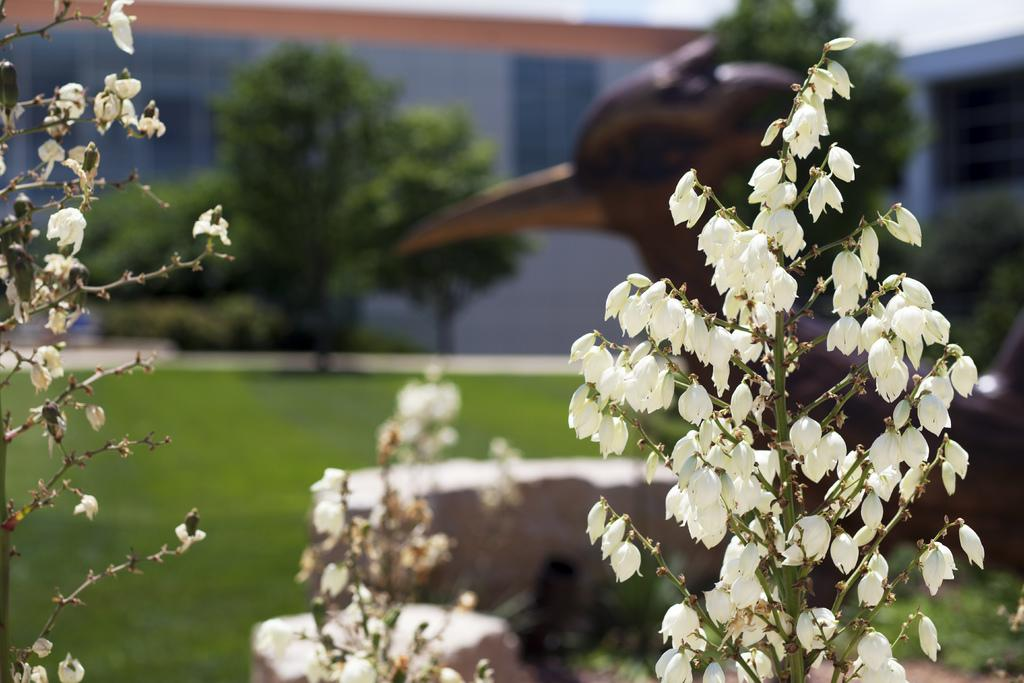What type of plants can be seen in the image? There are plants with white flowers in the image. What can be seen in the background of the image? There are trees, a building, and the sky visible in the background of the image. Can you see any ladybugs on the plants in the image? There are no ladybugs visible on the plants in the image. Is there a zoo present in the image? There is no zoo present in the image. 